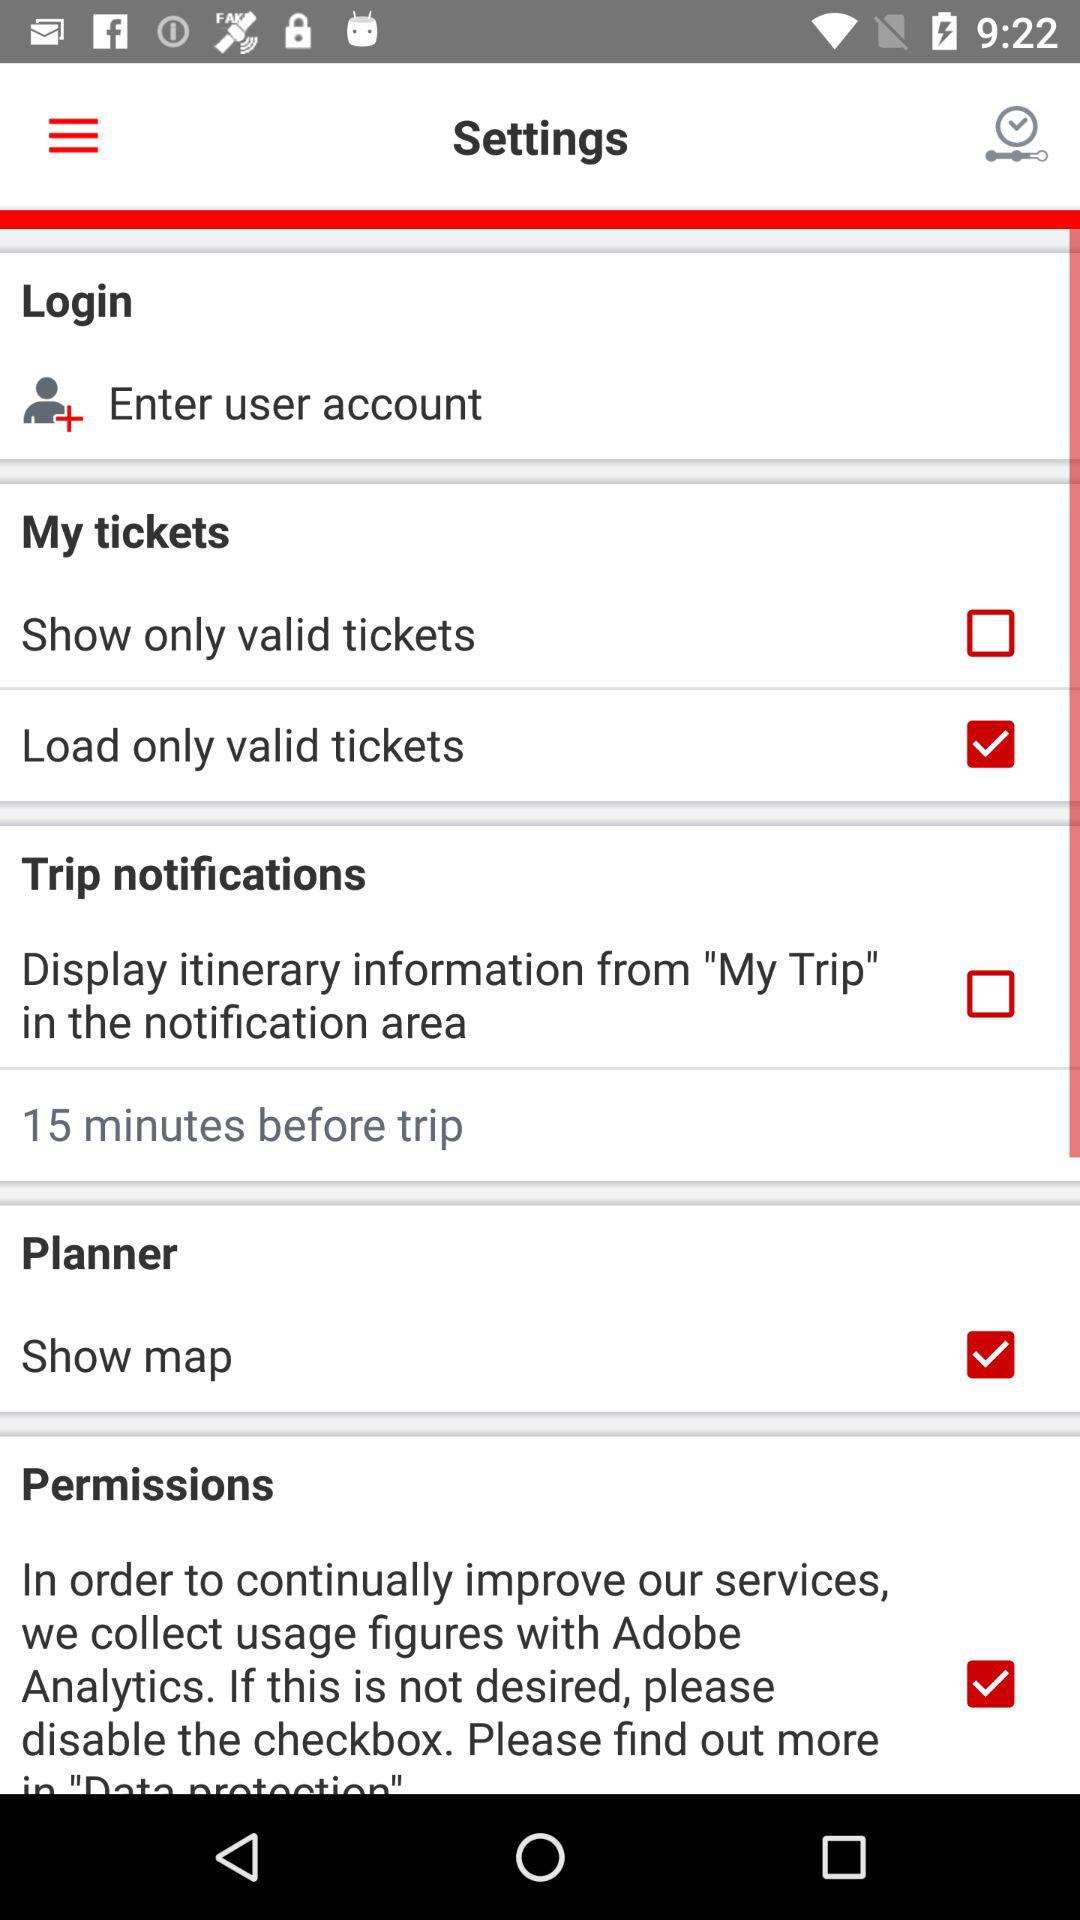What is the status of "Trip notifications"? The status is "off". 